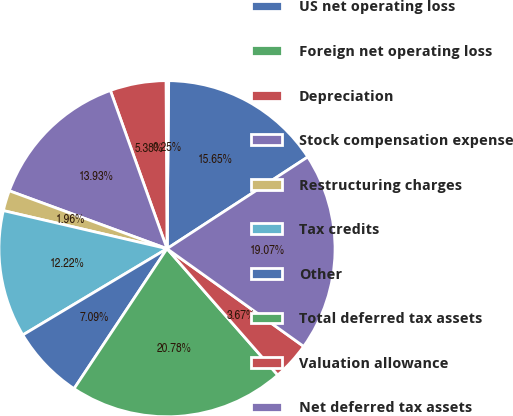<chart> <loc_0><loc_0><loc_500><loc_500><pie_chart><fcel>US net operating loss<fcel>Foreign net operating loss<fcel>Depreciation<fcel>Stock compensation expense<fcel>Restructuring charges<fcel>Tax credits<fcel>Other<fcel>Total deferred tax assets<fcel>Valuation allowance<fcel>Net deferred tax assets<nl><fcel>15.65%<fcel>0.25%<fcel>5.38%<fcel>13.93%<fcel>1.96%<fcel>12.22%<fcel>7.09%<fcel>20.78%<fcel>3.67%<fcel>19.07%<nl></chart> 